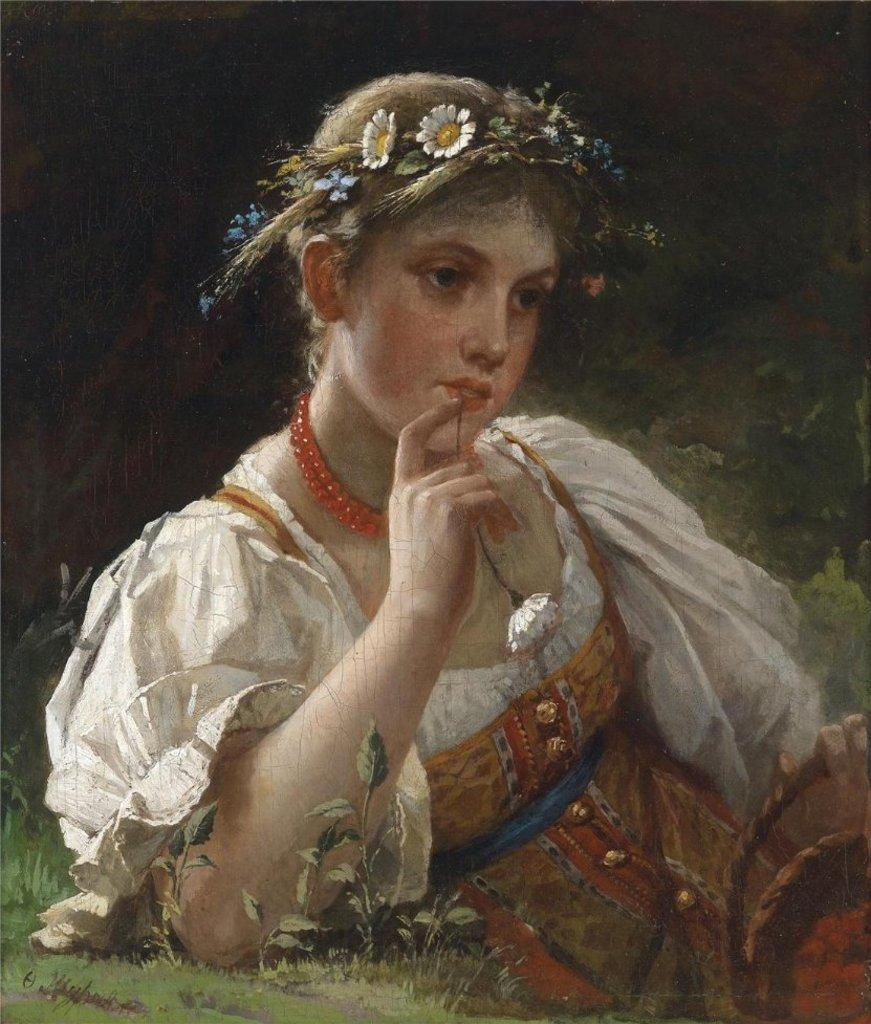Who is the main subject in the painting? A: There is a woman in the painting. What is the woman doing in the painting? The woman is laying on the grass. What is the woman wearing in her hair? The woman is wearing a flower hair band. What object is the woman holding in her hand? The woman is holding a white flower in her hand. What type of clouds can be seen in the painting? There are no clouds visible in the painting; it is focused on the woman laying on the grass and her accessories. 